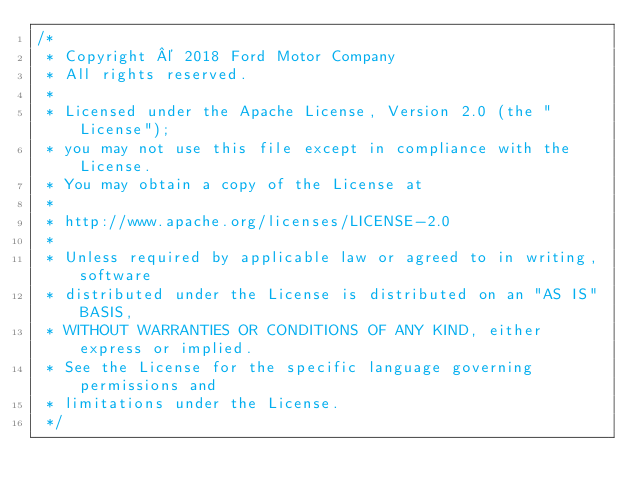<code> <loc_0><loc_0><loc_500><loc_500><_Java_>/*
 * Copyright © 2018 Ford Motor Company
 * All rights reserved.
 *
 * Licensed under the Apache License, Version 2.0 (the "License");
 * you may not use this file except in compliance with the License.
 * You may obtain a copy of the License at
 *
 * http://www.apache.org/licenses/LICENSE-2.0
 *
 * Unless required by applicable law or agreed to in writing, software
 * distributed under the License is distributed on an "AS IS" BASIS,
 * WITHOUT WARRANTIES OR CONDITIONS OF ANY KIND, either express or implied.
 * See the License for the specific language governing permissions and
 * limitations under the License.
 */
</code> 